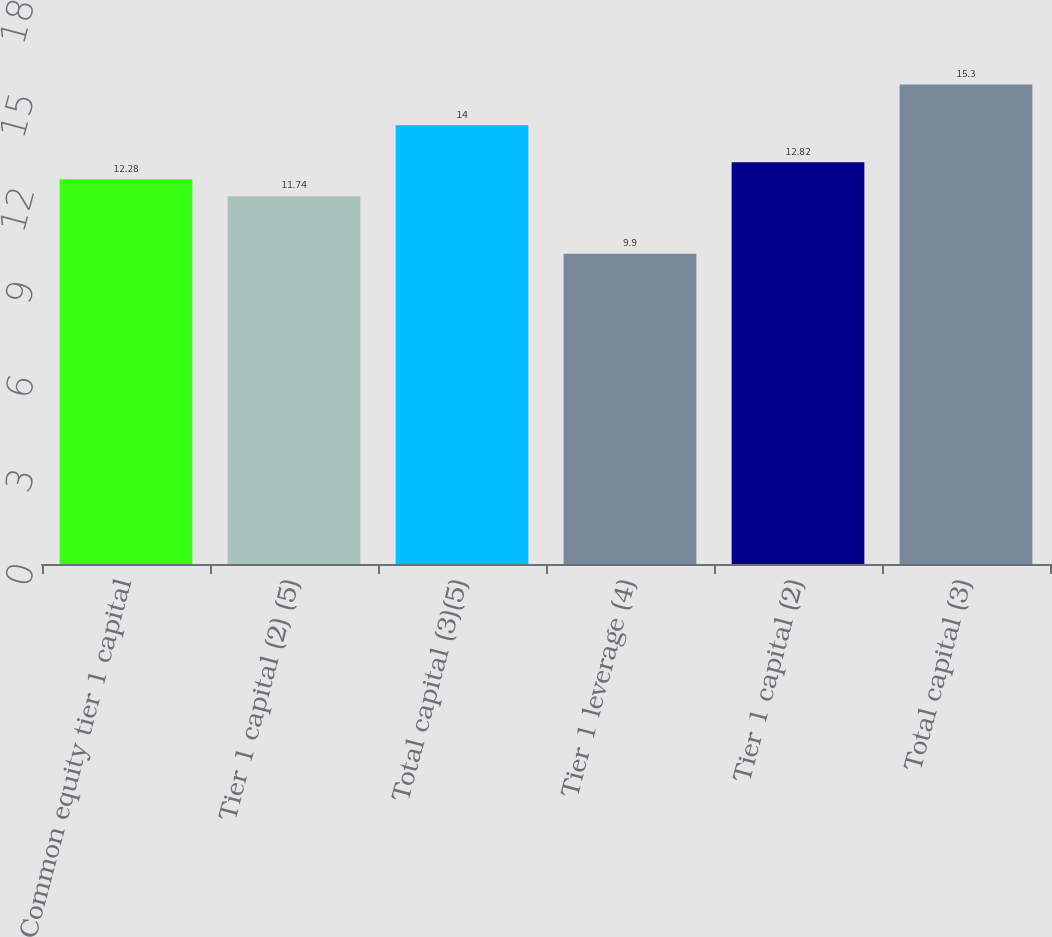Convert chart to OTSL. <chart><loc_0><loc_0><loc_500><loc_500><bar_chart><fcel>Common equity tier 1 capital<fcel>Tier 1 capital (2) (5)<fcel>Total capital (3)(5)<fcel>Tier 1 leverage (4)<fcel>Tier 1 capital (2)<fcel>Total capital (3)<nl><fcel>12.28<fcel>11.74<fcel>14<fcel>9.9<fcel>12.82<fcel>15.3<nl></chart> 